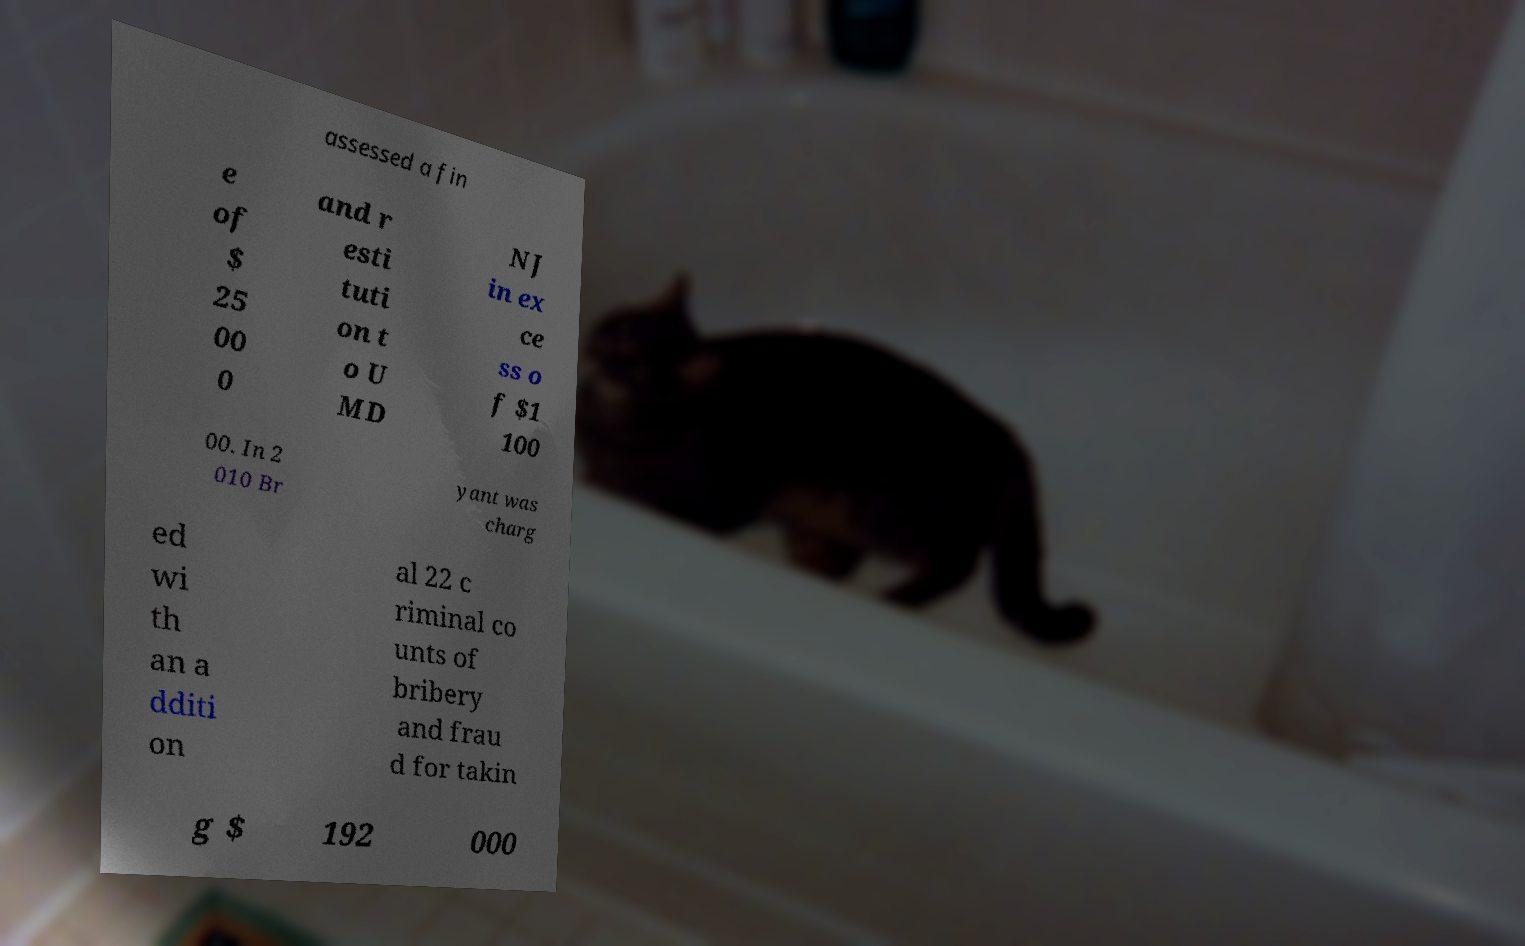Can you read and provide the text displayed in the image?This photo seems to have some interesting text. Can you extract and type it out for me? assessed a fin e of $ 25 00 0 and r esti tuti on t o U MD NJ in ex ce ss o f $1 100 00. In 2 010 Br yant was charg ed wi th an a dditi on al 22 c riminal co unts of bribery and frau d for takin g $ 192 000 